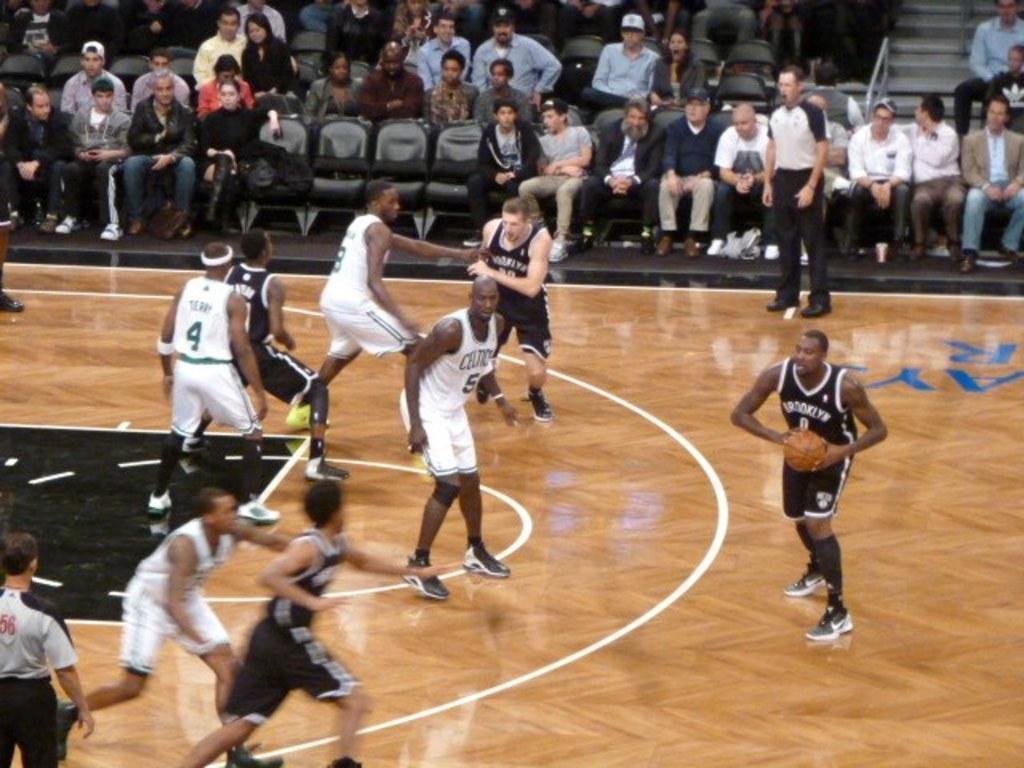Describe this image in one or two sentences. In this image few players are playing on the basketball court. This person is holding basketball. In the background people are sitting on the chairs. They are watching the game. Here there are stairs. 